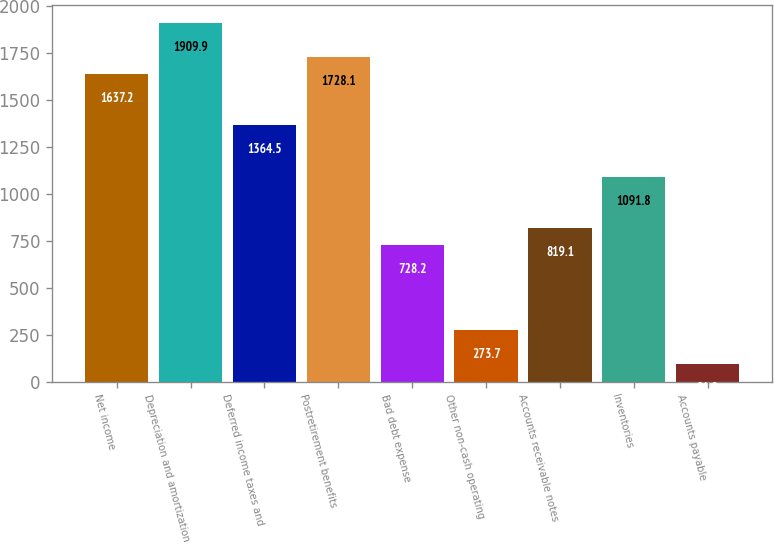<chart> <loc_0><loc_0><loc_500><loc_500><bar_chart><fcel>Net income<fcel>Depreciation and amortization<fcel>Deferred income taxes and<fcel>Postretirement benefits<fcel>Bad debt expense<fcel>Other non-cash operating<fcel>Accounts receivable notes<fcel>Inventories<fcel>Accounts payable<nl><fcel>1637.2<fcel>1909.9<fcel>1364.5<fcel>1728.1<fcel>728.2<fcel>273.7<fcel>819.1<fcel>1091.8<fcel>91.9<nl></chart> 